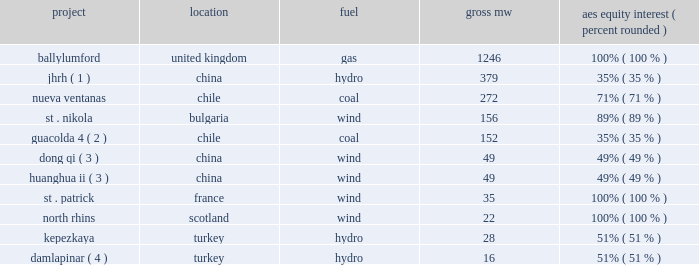2022 integration of new projects .
During 2010 , the following projects were acquired or commenced commercial operations : project location fuel aes equity interest ( percent , rounded ) .
Damlapinar ( 4 ) .
Turkey hydro 16 51% ( 51 % ) ( 1 ) jianghe rural electrification development co .
Ltd .
( 201cjhrh 201d ) and aes china hydropower investment co .
Ltd .
Entered into an agreement to acquire a 49% ( 49 % ) interest in this joint venture in june 2010 .
Acquisition of 35% ( 35 % ) ownership was completed in june 2010 and the transfer of the remaining 14% ( 14 % ) ownership , which is subject to approval by the chinese government , is expected to be completed in may 2011 .
( 2 ) guacolda is an equity method investment indirectly held by aes through gener .
The aes equity interest reflects the 29% ( 29 % ) noncontrolling interests in gener .
( 3 ) joint venture with guohua energy investment co .
Ltd .
( 4 ) joint venture with i.c .
Energy .
Key trends and uncertainties our operations continue to face many risks as discussed in item 1a . 2014risk factors of this form 10-k .
Some of these challenges are also described above in key drivers of results in 2010 .
We continue to monitor our operations and address challenges as they arise .
Development .
During the past year , the company has successfully acquired and completed construction of a number of projects , totaling approximately 2404 mw , including the acquisition of ballylumford in the united kingdom and completion of construction of a number of projects in europe , chile and china .
However , as discussed in item 1a . 2014risk factors 2014our business is subject to substantial development uncertainties of this form 10-k , our development projects are subject to uncertainties .
Certain delays have occurred at the 670 mw maritza coal-fired project in bulgaria , and the project has not yet begun commercial operations .
As noted in note 10 2014debt included in item 8 of this form 10-k , as a result of these delays the project debt is in default and the company is working with its lenders to resolve the default .
In addition , as noted in item 3 . 2014legal proceedings , the company is in litigation with the contractor regarding the cause of delays .
At this time , we believe that maritza will commence commercial operations for at least some of the project 2019s capacity by the second half of 2011 .
However , commencement of commercial operations could be delayed beyond this time frame .
There can be no assurance that maritza will achieve commercial operations , in whole or in part , by the second half of 2011 , resolve the default with the lenders or prevail in the litigation referenced above , which could result in the loss of some or all of our investment or require additional funding for the project .
Any of these events could have a material adverse effect on the company 2019s operating results or financial position .
Global economic conditions .
During the past few years , economic conditions in some countries where our subsidiaries conduct business have deteriorated .
Although the economic conditions in several of these countries have improved in recent months , our businesses could be impacted in the event these recent trends do not continue. .
What percentage of mw from acquired or commenced commercial operations in 2010 were due to ballylumford in the united kingdom? 
Computations: (1246 / 2404)
Answer: 0.5183. 